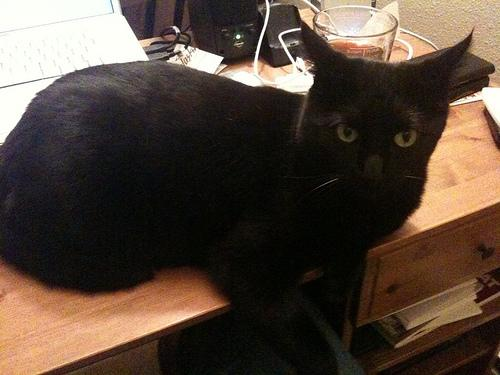What type of woman might this animal be associated with historically? witch 